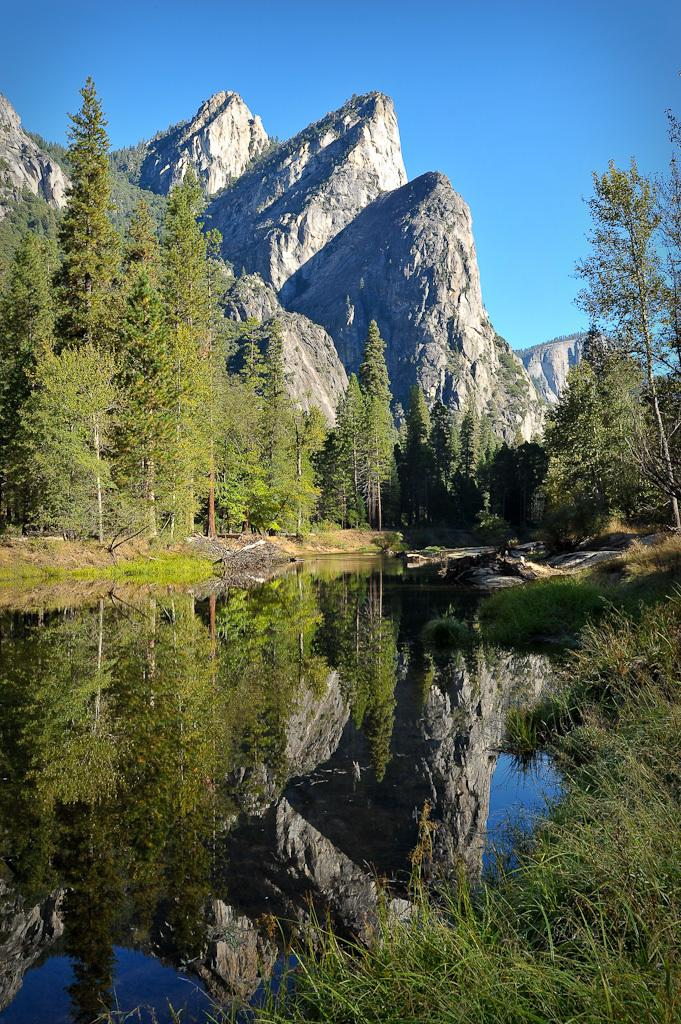What natural element can be seen in the image? Water is visible in the image. What type of vegetation is present in the image? There is grass and trees in the image. What geographical feature can be seen in the background of the image? There are mountains in the background of the image. What part of the sky is visible in the image? The sky is visible in the background of the image. Are there any giants visible in the image? No, there are no giants present in the image. What edge can be seen in the image? There is no specific edge mentioned or visible in the image. 